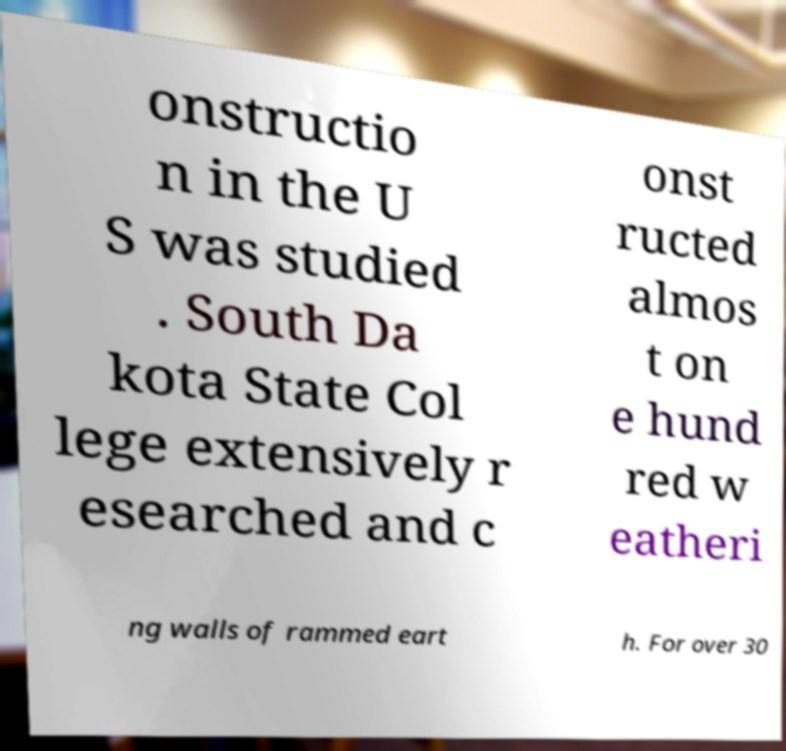I need the written content from this picture converted into text. Can you do that? onstructio n in the U S was studied . South Da kota State Col lege extensively r esearched and c onst ructed almos t on e hund red w eatheri ng walls of rammed eart h. For over 30 